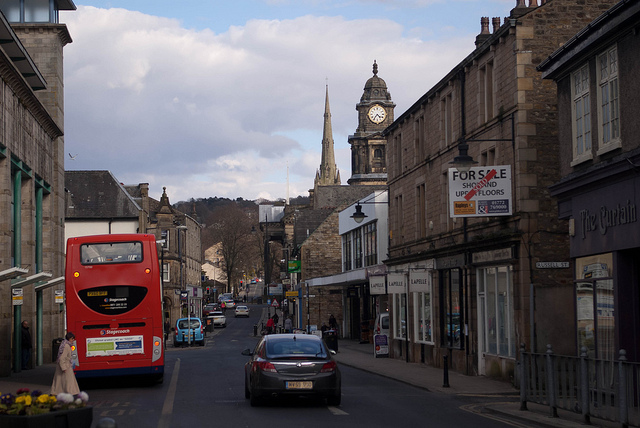Identify the text displayed in this image. FOR SALE FLOORS The 